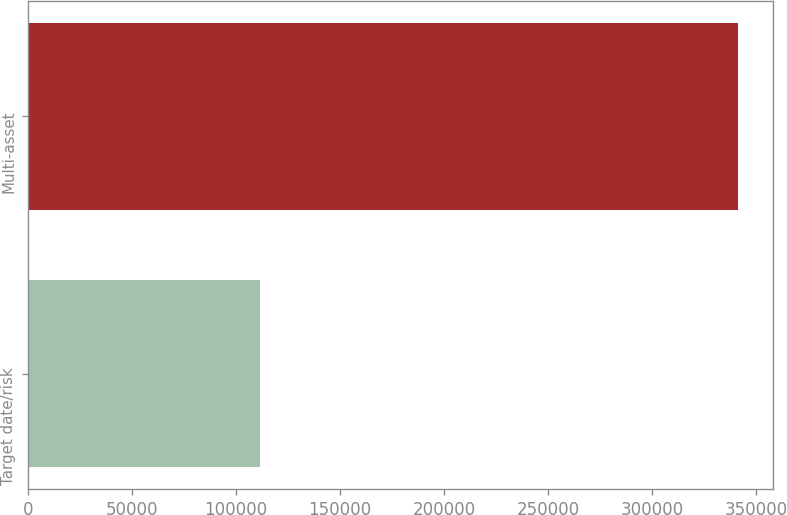Convert chart. <chart><loc_0><loc_0><loc_500><loc_500><bar_chart><fcel>Target date/risk<fcel>Multi-asset<nl><fcel>111408<fcel>341214<nl></chart> 